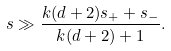<formula> <loc_0><loc_0><loc_500><loc_500>s \gg \frac { k ( d + 2 ) s _ { + } + s _ { - } } { k ( d + 2 ) + 1 } .</formula> 